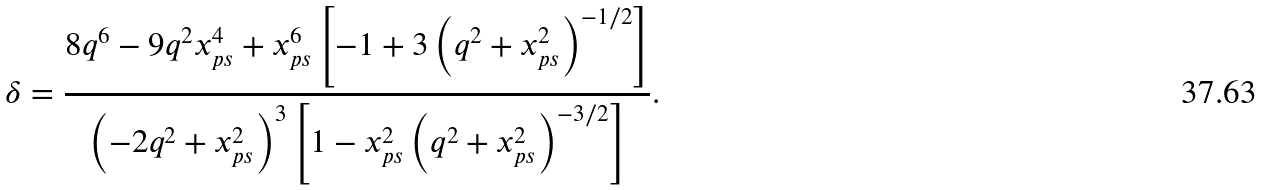Convert formula to latex. <formula><loc_0><loc_0><loc_500><loc_500>\delta = \frac { 8 q ^ { 6 } - 9 q ^ { 2 } x ^ { 4 } _ { p s } + x ^ { 6 } _ { p s } \left [ - 1 + 3 \left ( q ^ { 2 } + x ^ { 2 } _ { p s } \right ) ^ { - 1 / 2 } \right ] } { \left ( - 2 q ^ { 2 } + x ^ { 2 } _ { p s } \right ) ^ { 3 } \left [ 1 - x ^ { 2 } _ { p s } \left ( q ^ { 2 } + x ^ { 2 } _ { p s } \right ) ^ { - 3 / 2 } \right ] } .</formula> 